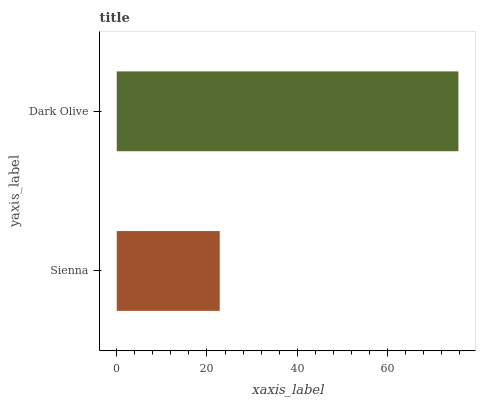Is Sienna the minimum?
Answer yes or no. Yes. Is Dark Olive the maximum?
Answer yes or no. Yes. Is Dark Olive the minimum?
Answer yes or no. No. Is Dark Olive greater than Sienna?
Answer yes or no. Yes. Is Sienna less than Dark Olive?
Answer yes or no. Yes. Is Sienna greater than Dark Olive?
Answer yes or no. No. Is Dark Olive less than Sienna?
Answer yes or no. No. Is Dark Olive the high median?
Answer yes or no. Yes. Is Sienna the low median?
Answer yes or no. Yes. Is Sienna the high median?
Answer yes or no. No. Is Dark Olive the low median?
Answer yes or no. No. 